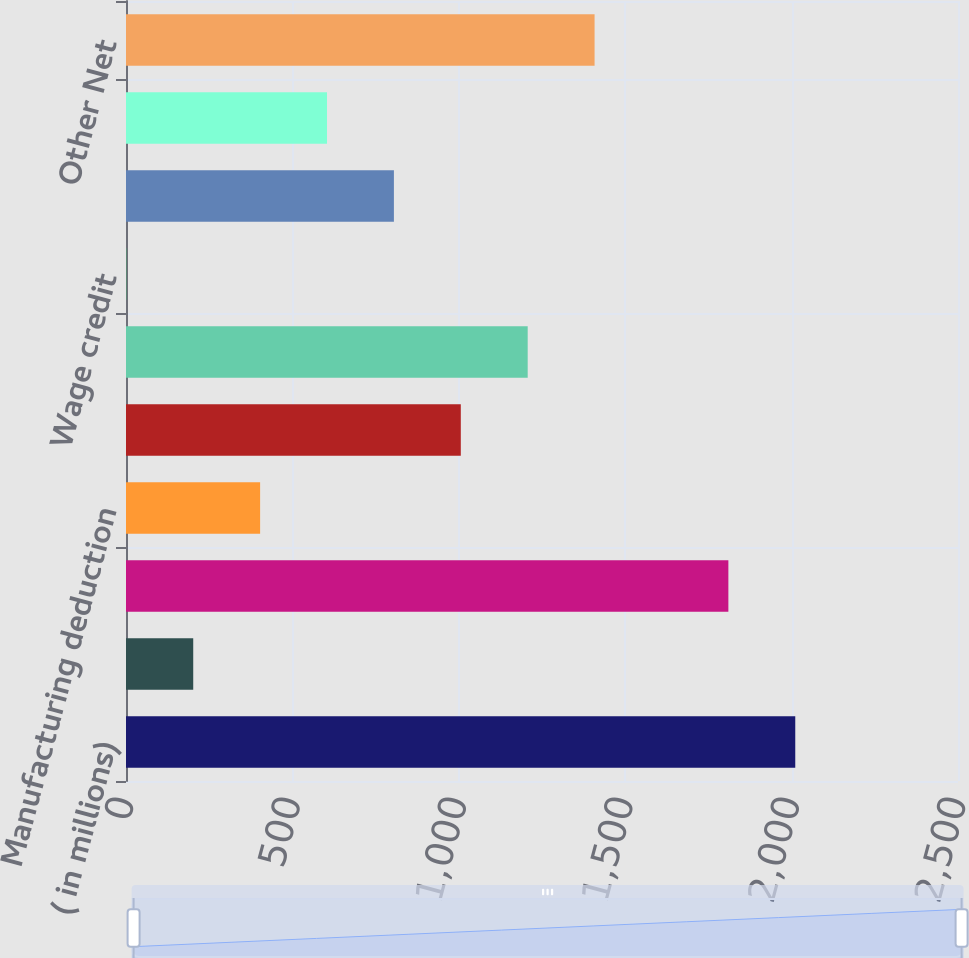Convert chart. <chart><loc_0><loc_0><loc_500><loc_500><bar_chart><fcel>( in millions)<fcel>Income tax expense (benefit)<fcel>Goodwill impairment<fcel>Manufacturing deduction<fcel>Research tax credit<fcel>Medicare Part D law change<fcel>Wage credit<fcel>IRS settlement<fcel>Tax Matters Agreement<fcel>Other Net<nl><fcel>2011<fcel>202<fcel>1810<fcel>403<fcel>1006<fcel>1207<fcel>1<fcel>805<fcel>604<fcel>1408<nl></chart> 